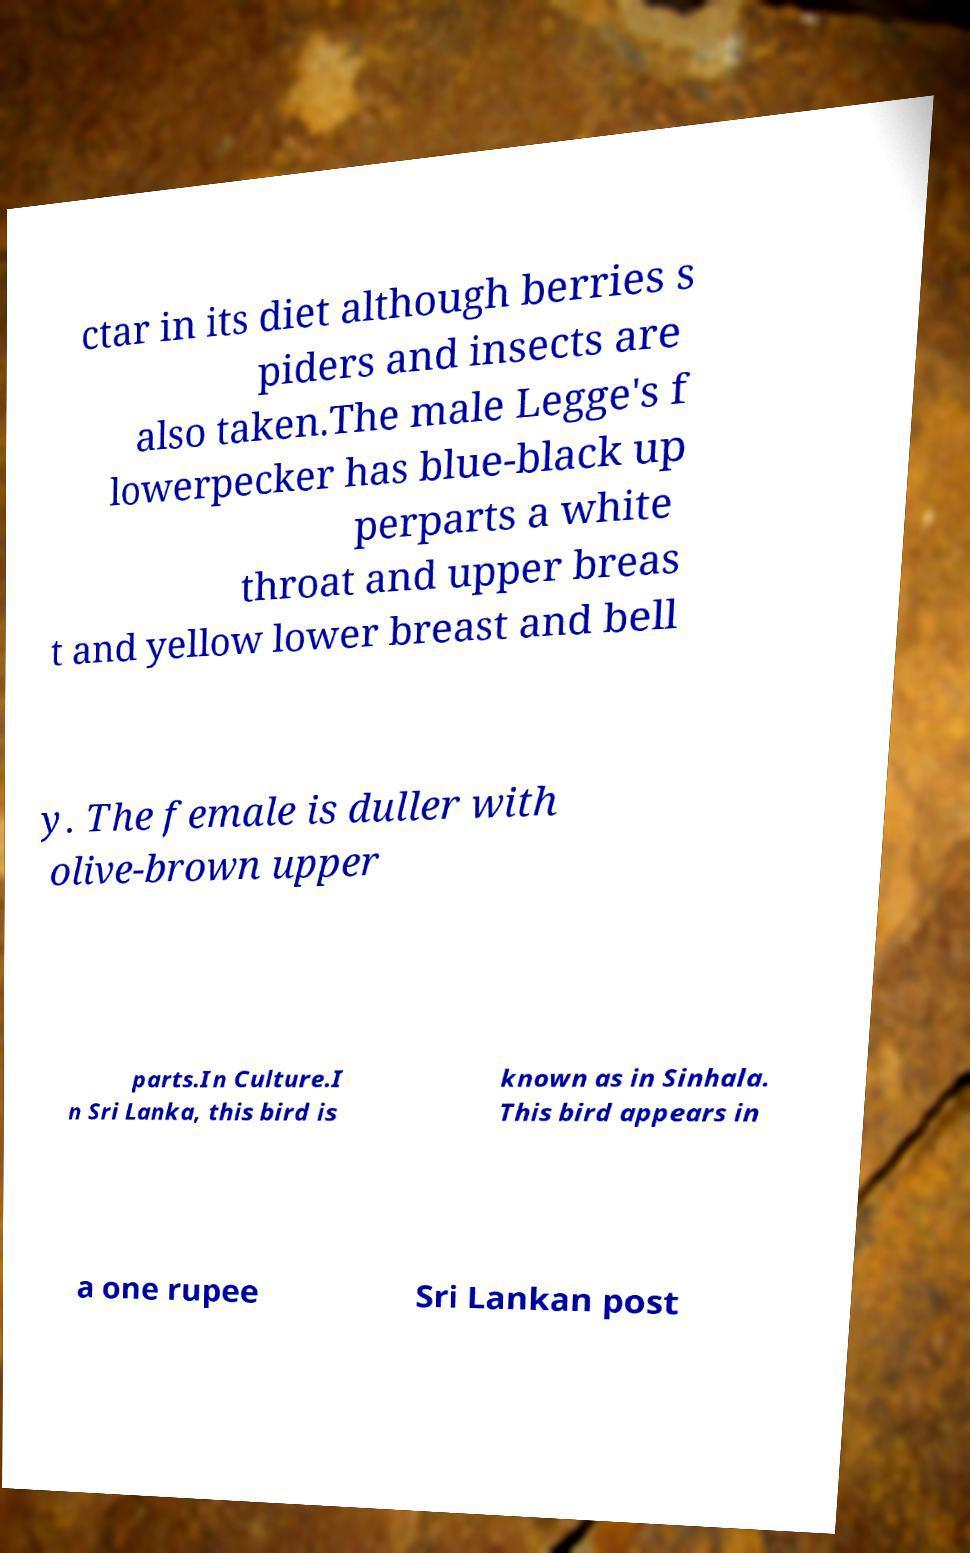There's text embedded in this image that I need extracted. Can you transcribe it verbatim? ctar in its diet although berries s piders and insects are also taken.The male Legge's f lowerpecker has blue-black up perparts a white throat and upper breas t and yellow lower breast and bell y. The female is duller with olive-brown upper parts.In Culture.I n Sri Lanka, this bird is known as in Sinhala. This bird appears in a one rupee Sri Lankan post 